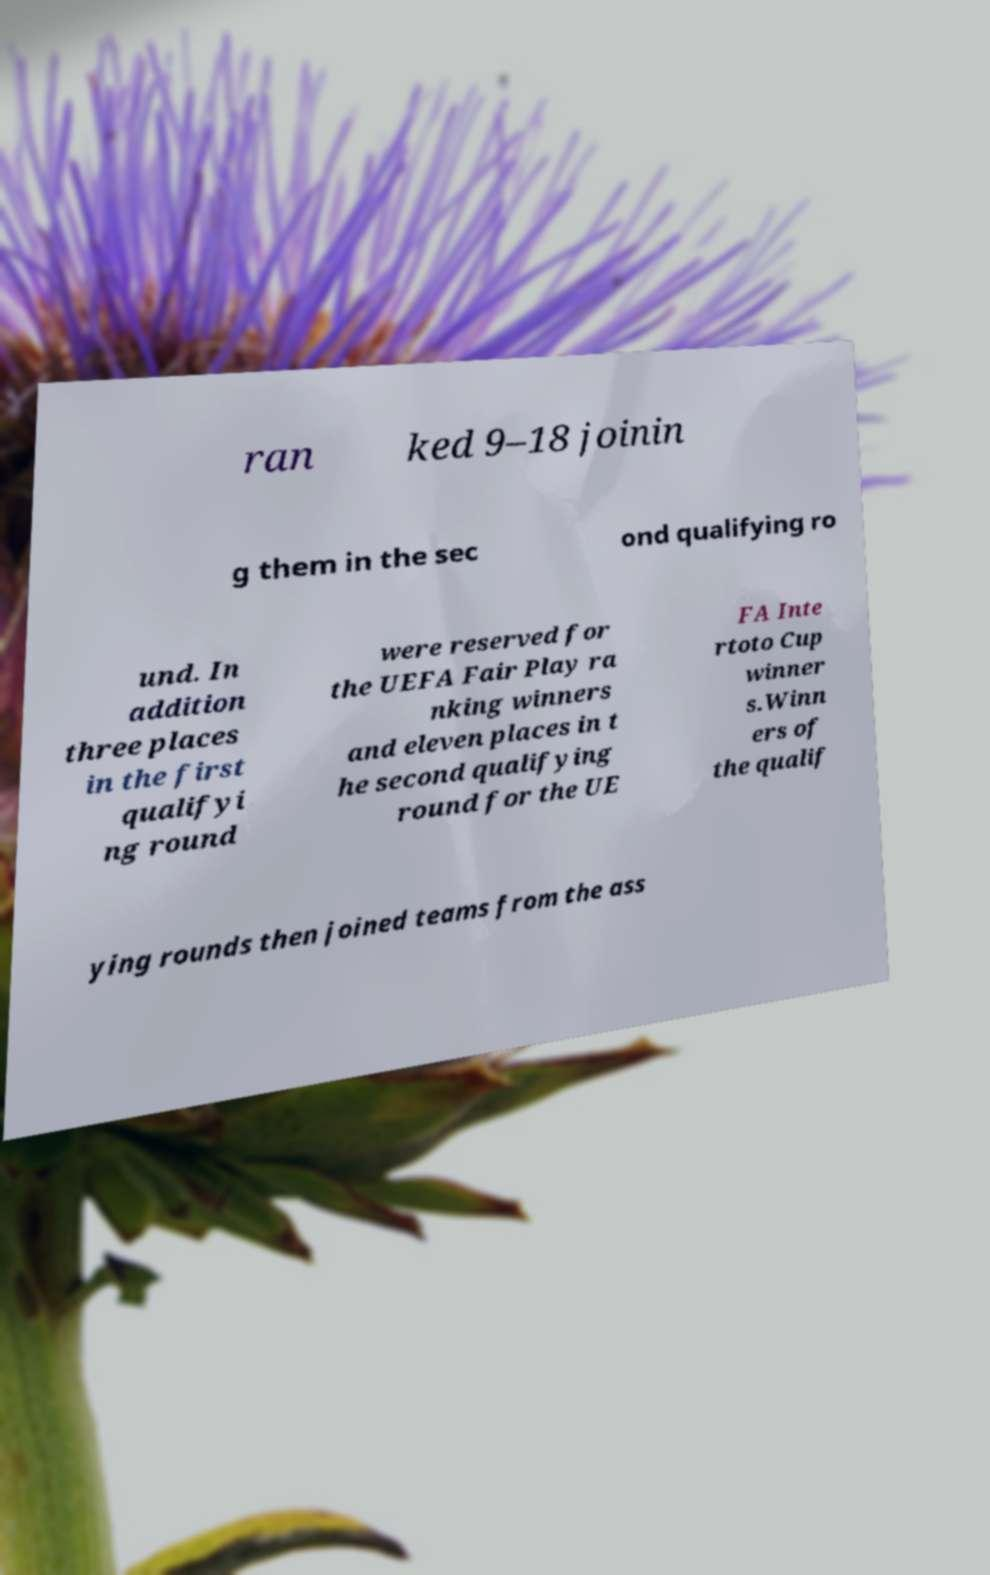Can you read and provide the text displayed in the image?This photo seems to have some interesting text. Can you extract and type it out for me? ran ked 9–18 joinin g them in the sec ond qualifying ro und. In addition three places in the first qualifyi ng round were reserved for the UEFA Fair Play ra nking winners and eleven places in t he second qualifying round for the UE FA Inte rtoto Cup winner s.Winn ers of the qualif ying rounds then joined teams from the ass 